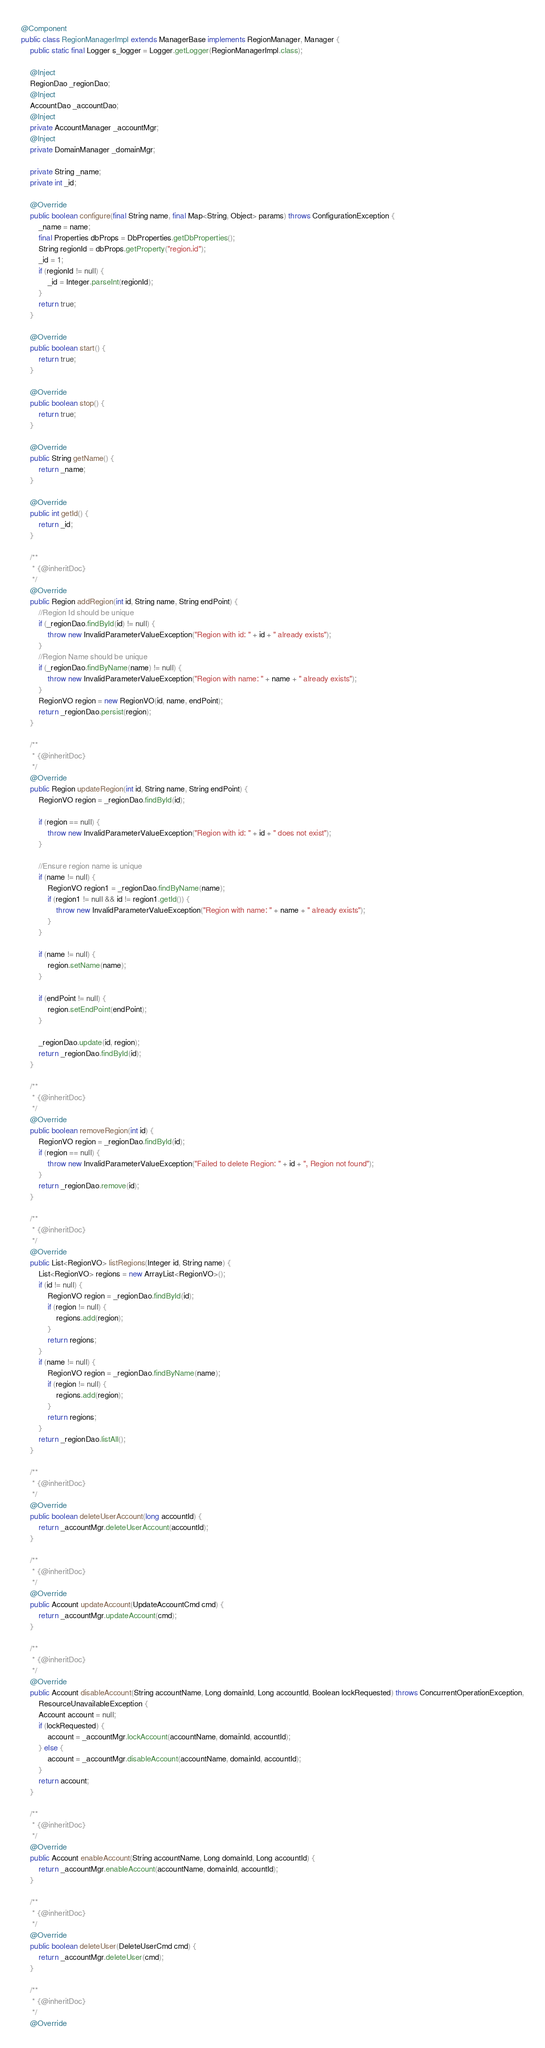<code> <loc_0><loc_0><loc_500><loc_500><_Java_>@Component
public class RegionManagerImpl extends ManagerBase implements RegionManager, Manager {
    public static final Logger s_logger = Logger.getLogger(RegionManagerImpl.class);

    @Inject
    RegionDao _regionDao;
    @Inject
    AccountDao _accountDao;
    @Inject
    private AccountManager _accountMgr;
    @Inject
    private DomainManager _domainMgr;

    private String _name;
    private int _id;

    @Override
    public boolean configure(final String name, final Map<String, Object> params) throws ConfigurationException {
        _name = name;
        final Properties dbProps = DbProperties.getDbProperties();
        String regionId = dbProps.getProperty("region.id");
        _id = 1;
        if (regionId != null) {
            _id = Integer.parseInt(regionId);
        }
        return true;
    }

    @Override
    public boolean start() {
        return true;
    }

    @Override
    public boolean stop() {
        return true;
    }

    @Override
    public String getName() {
        return _name;
    }

    @Override
    public int getId() {
        return _id;
    }

    /**
     * {@inheritDoc}
     */
    @Override
    public Region addRegion(int id, String name, String endPoint) {
        //Region Id should be unique
        if (_regionDao.findById(id) != null) {
            throw new InvalidParameterValueException("Region with id: " + id + " already exists");
        }
        //Region Name should be unique
        if (_regionDao.findByName(name) != null) {
            throw new InvalidParameterValueException("Region with name: " + name + " already exists");
        }
        RegionVO region = new RegionVO(id, name, endPoint);
        return _regionDao.persist(region);
    }

    /**
     * {@inheritDoc}
     */
    @Override
    public Region updateRegion(int id, String name, String endPoint) {
        RegionVO region = _regionDao.findById(id);

        if (region == null) {
            throw new InvalidParameterValueException("Region with id: " + id + " does not exist");
        }

        //Ensure region name is unique
        if (name != null) {
            RegionVO region1 = _regionDao.findByName(name);
            if (region1 != null && id != region1.getId()) {
                throw new InvalidParameterValueException("Region with name: " + name + " already exists");
            }
        }

        if (name != null) {
            region.setName(name);
        }

        if (endPoint != null) {
            region.setEndPoint(endPoint);
        }

        _regionDao.update(id, region);
        return _regionDao.findById(id);
    }

    /**
     * {@inheritDoc}
     */
    @Override
    public boolean removeRegion(int id) {
        RegionVO region = _regionDao.findById(id);
        if (region == null) {
            throw new InvalidParameterValueException("Failed to delete Region: " + id + ", Region not found");
        }
        return _regionDao.remove(id);
    }

    /**
     * {@inheritDoc}
     */
    @Override
    public List<RegionVO> listRegions(Integer id, String name) {
        List<RegionVO> regions = new ArrayList<RegionVO>();
        if (id != null) {
            RegionVO region = _regionDao.findById(id);
            if (region != null) {
                regions.add(region);
            }
            return regions;
        }
        if (name != null) {
            RegionVO region = _regionDao.findByName(name);
            if (region != null) {
                regions.add(region);
            }
            return regions;
        }
        return _regionDao.listAll();
    }

    /**
     * {@inheritDoc}
     */
    @Override
    public boolean deleteUserAccount(long accountId) {
        return _accountMgr.deleteUserAccount(accountId);
    }

    /**
     * {@inheritDoc}
     */
    @Override
    public Account updateAccount(UpdateAccountCmd cmd) {
        return _accountMgr.updateAccount(cmd);
    }

    /**
     * {@inheritDoc}
     */
    @Override
    public Account disableAccount(String accountName, Long domainId, Long accountId, Boolean lockRequested) throws ConcurrentOperationException,
        ResourceUnavailableException {
        Account account = null;
        if (lockRequested) {
            account = _accountMgr.lockAccount(accountName, domainId, accountId);
        } else {
            account = _accountMgr.disableAccount(accountName, domainId, accountId);
        }
        return account;
    }

    /**
     * {@inheritDoc}
     */
    @Override
    public Account enableAccount(String accountName, Long domainId, Long accountId) {
        return _accountMgr.enableAccount(accountName, domainId, accountId);
    }

    /**
     * {@inheritDoc}
     */
    @Override
    public boolean deleteUser(DeleteUserCmd cmd) {
        return _accountMgr.deleteUser(cmd);
    }

    /**
     * {@inheritDoc}
     */
    @Override</code> 